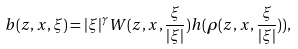Convert formula to latex. <formula><loc_0><loc_0><loc_500><loc_500>b ( z , x , \xi ) = | \xi | ^ { \gamma } W ( z , x , \frac { \xi } { | \xi | } ) h ( \rho ( z , x , \frac { \xi } { | \xi | } ) ) ,</formula> 